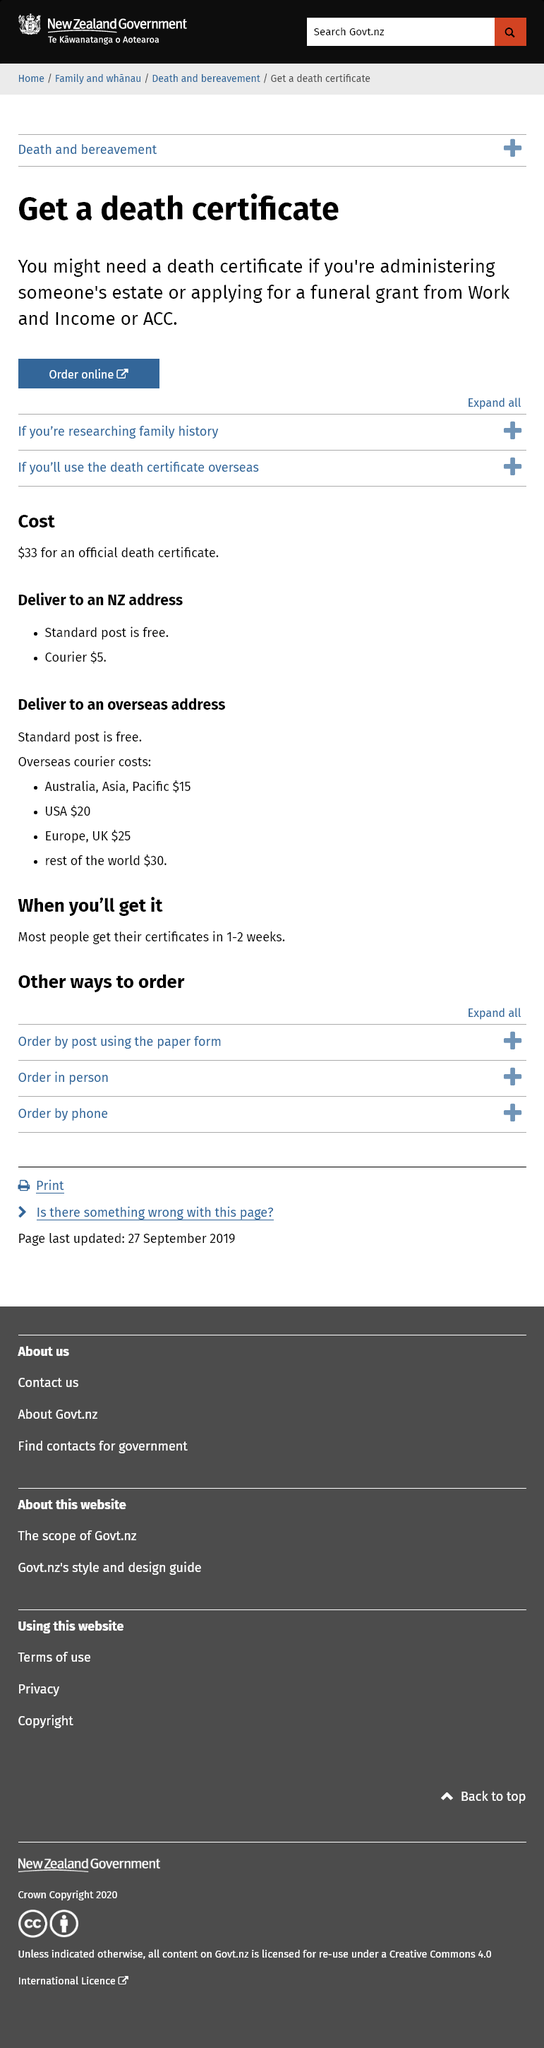Give some essential details in this illustration. It is estimated that the cost of having a death certificate from New Zealand mailed to the United States through the standard post service is free, while using a courier service will cost approximately $20. Yes, it is possible to order a death certificate online, and the cost is $33, plus shipping fees if applicable. The shipping cost within New Zealand is free for standard post and $5 for courier service. There are a total of three other ways to order the certificate. It is likely that the recipient will receive their certificate within 1-2 weeks. 